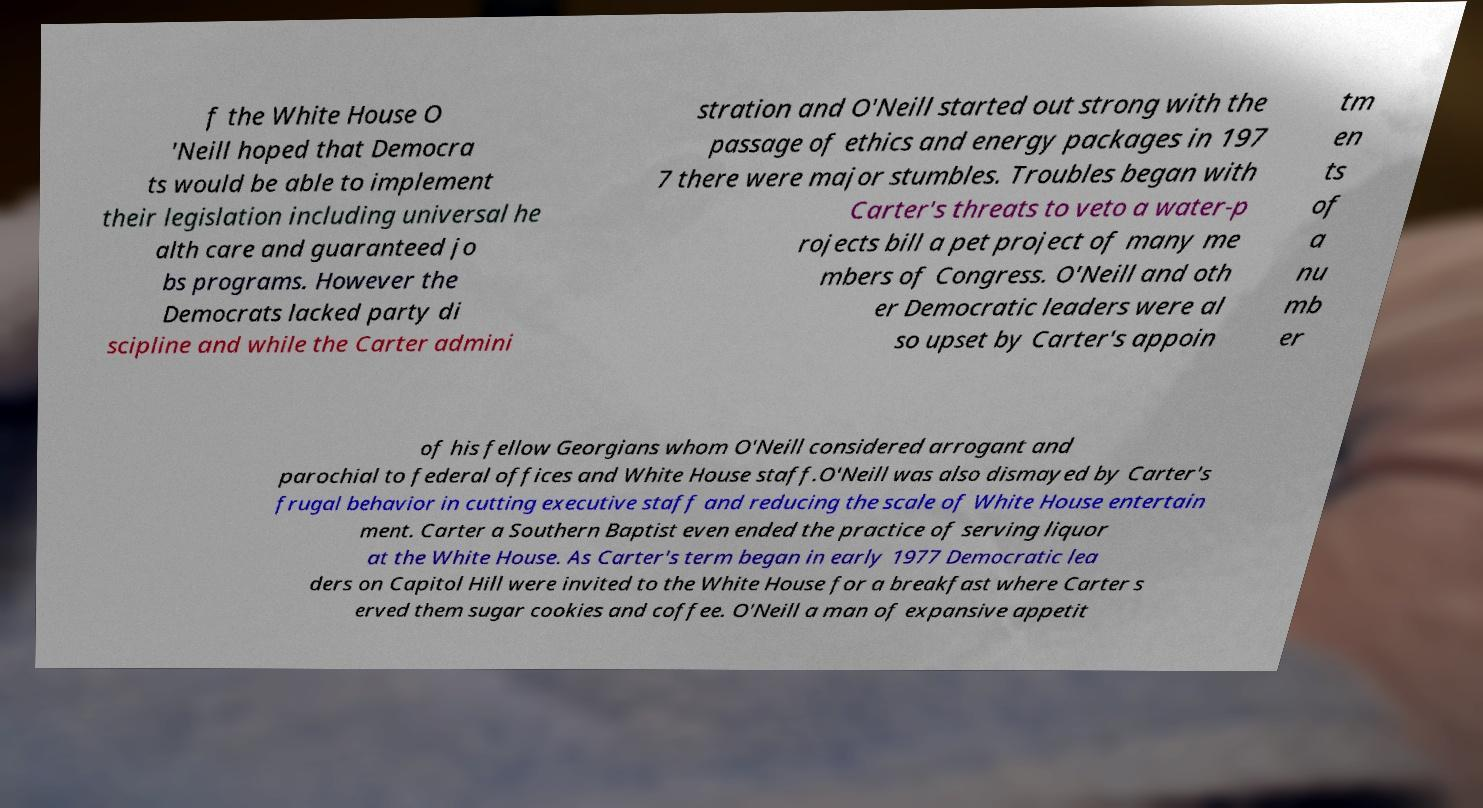What messages or text are displayed in this image? I need them in a readable, typed format. f the White House O 'Neill hoped that Democra ts would be able to implement their legislation including universal he alth care and guaranteed jo bs programs. However the Democrats lacked party di scipline and while the Carter admini stration and O'Neill started out strong with the passage of ethics and energy packages in 197 7 there were major stumbles. Troubles began with Carter's threats to veto a water-p rojects bill a pet project of many me mbers of Congress. O'Neill and oth er Democratic leaders were al so upset by Carter's appoin tm en ts of a nu mb er of his fellow Georgians whom O'Neill considered arrogant and parochial to federal offices and White House staff.O'Neill was also dismayed by Carter's frugal behavior in cutting executive staff and reducing the scale of White House entertain ment. Carter a Southern Baptist even ended the practice of serving liquor at the White House. As Carter's term began in early 1977 Democratic lea ders on Capitol Hill were invited to the White House for a breakfast where Carter s erved them sugar cookies and coffee. O'Neill a man of expansive appetit 